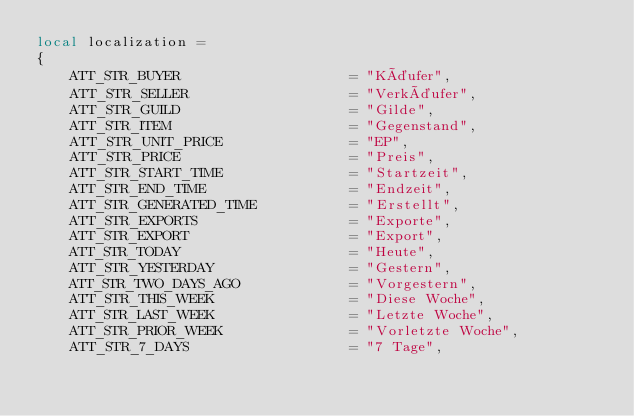<code> <loc_0><loc_0><loc_500><loc_500><_Lua_>local localization =
{
    ATT_STR_BUYER                    = "Käufer",
    ATT_STR_SELLER                   = "Verkäufer",
    ATT_STR_GUILD                    = "Gilde",
    ATT_STR_ITEM                     = "Gegenstand",
	ATT_STR_UNIT_PRICE               = "EP",
    ATT_STR_PRICE                    = "Preis",
    ATT_STR_START_TIME               = "Startzeit",
    ATT_STR_END_TIME                 = "Endzeit",
    ATT_STR_GENERATED_TIME           = "Erstellt",
    ATT_STR_EXPORTS                  = "Exporte",
    ATT_STR_EXPORT                   = "Export",
    ATT_STR_TODAY                    = "Heute",
    ATT_STR_YESTERDAY                = "Gestern",
    ATT_STR_TWO_DAYS_AGO             = "Vorgestern",
    ATT_STR_THIS_WEEK                = "Diese Woche",
    ATT_STR_LAST_WEEK                = "Letzte Woche",
    ATT_STR_PRIOR_WEEK               = "Vorletzte Woche",
    ATT_STR_7_DAYS                   = "7 Tage",</code> 